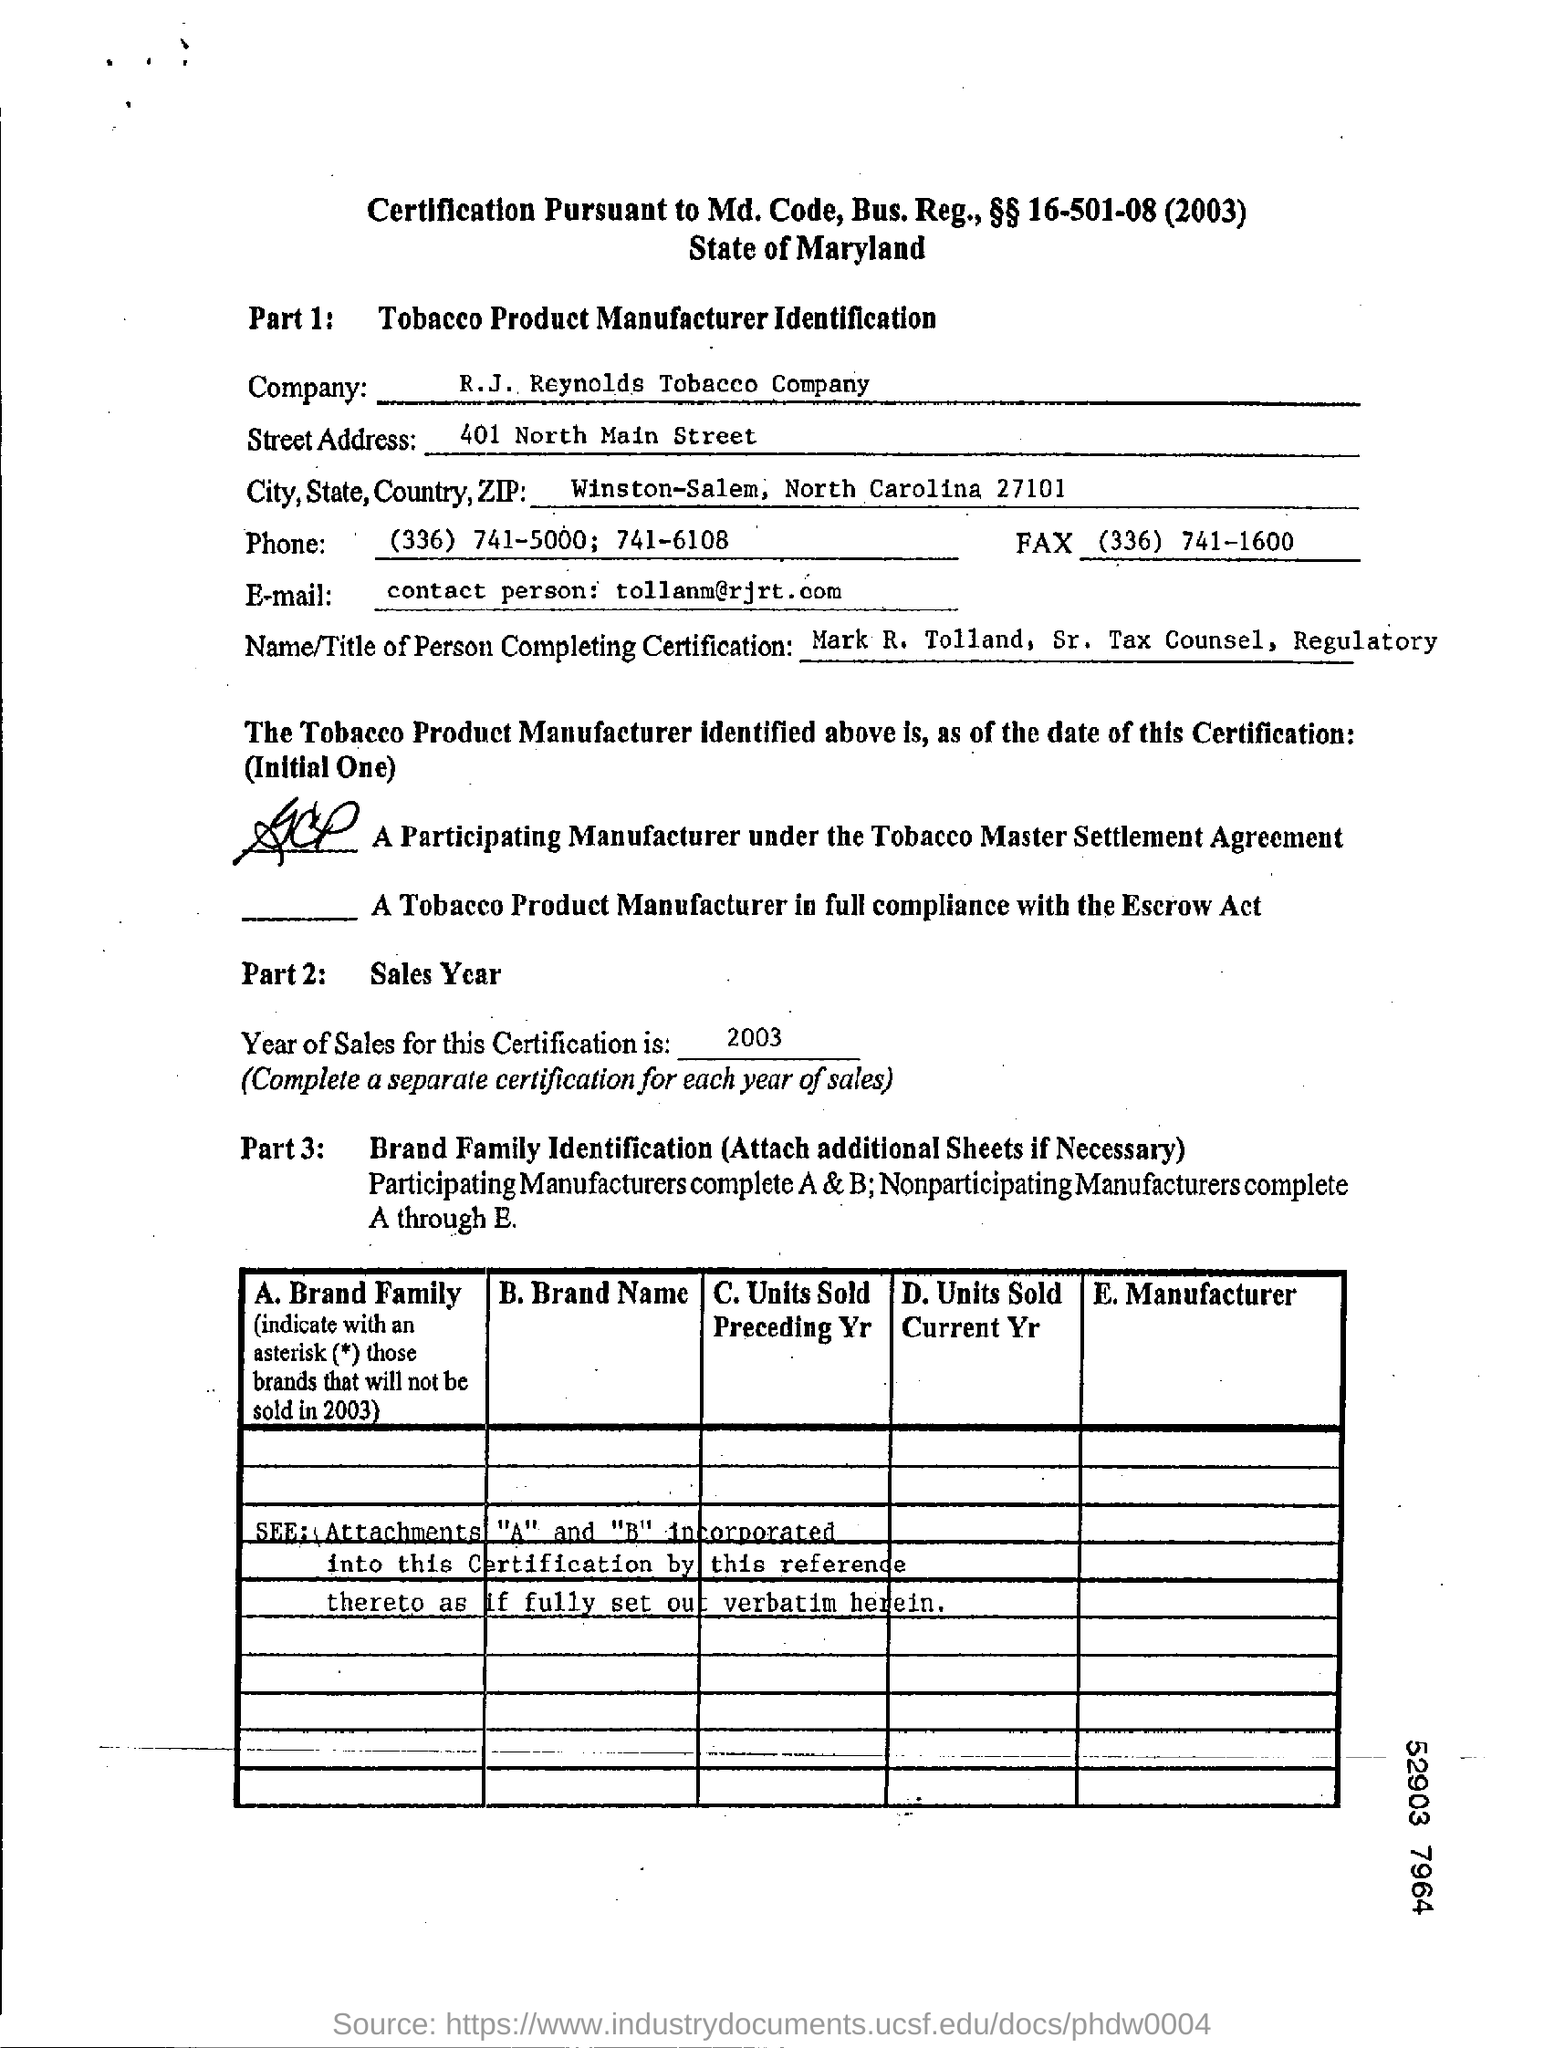Identify some key points in this picture. The R.J. Reynolds Tobacco Company is the name of a company. The email ID of R.J. Reynolds Tobacco Company is [tollanm@rjrt.com](mailto:tollanm@rjrt.com). 